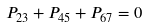<formula> <loc_0><loc_0><loc_500><loc_500>P _ { 2 3 } + P _ { 4 5 } + P _ { 6 7 } = 0</formula> 